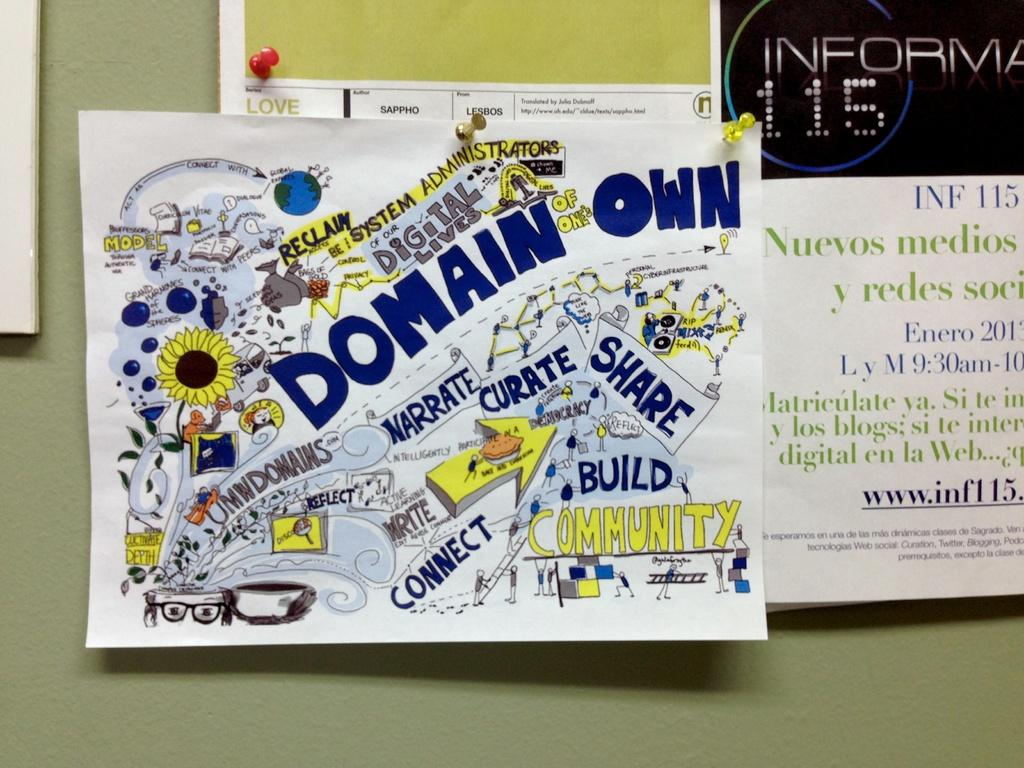<image>
Relay a brief, clear account of the picture shown. A piece of paper which has the words Domain Own on it, amongst others. 